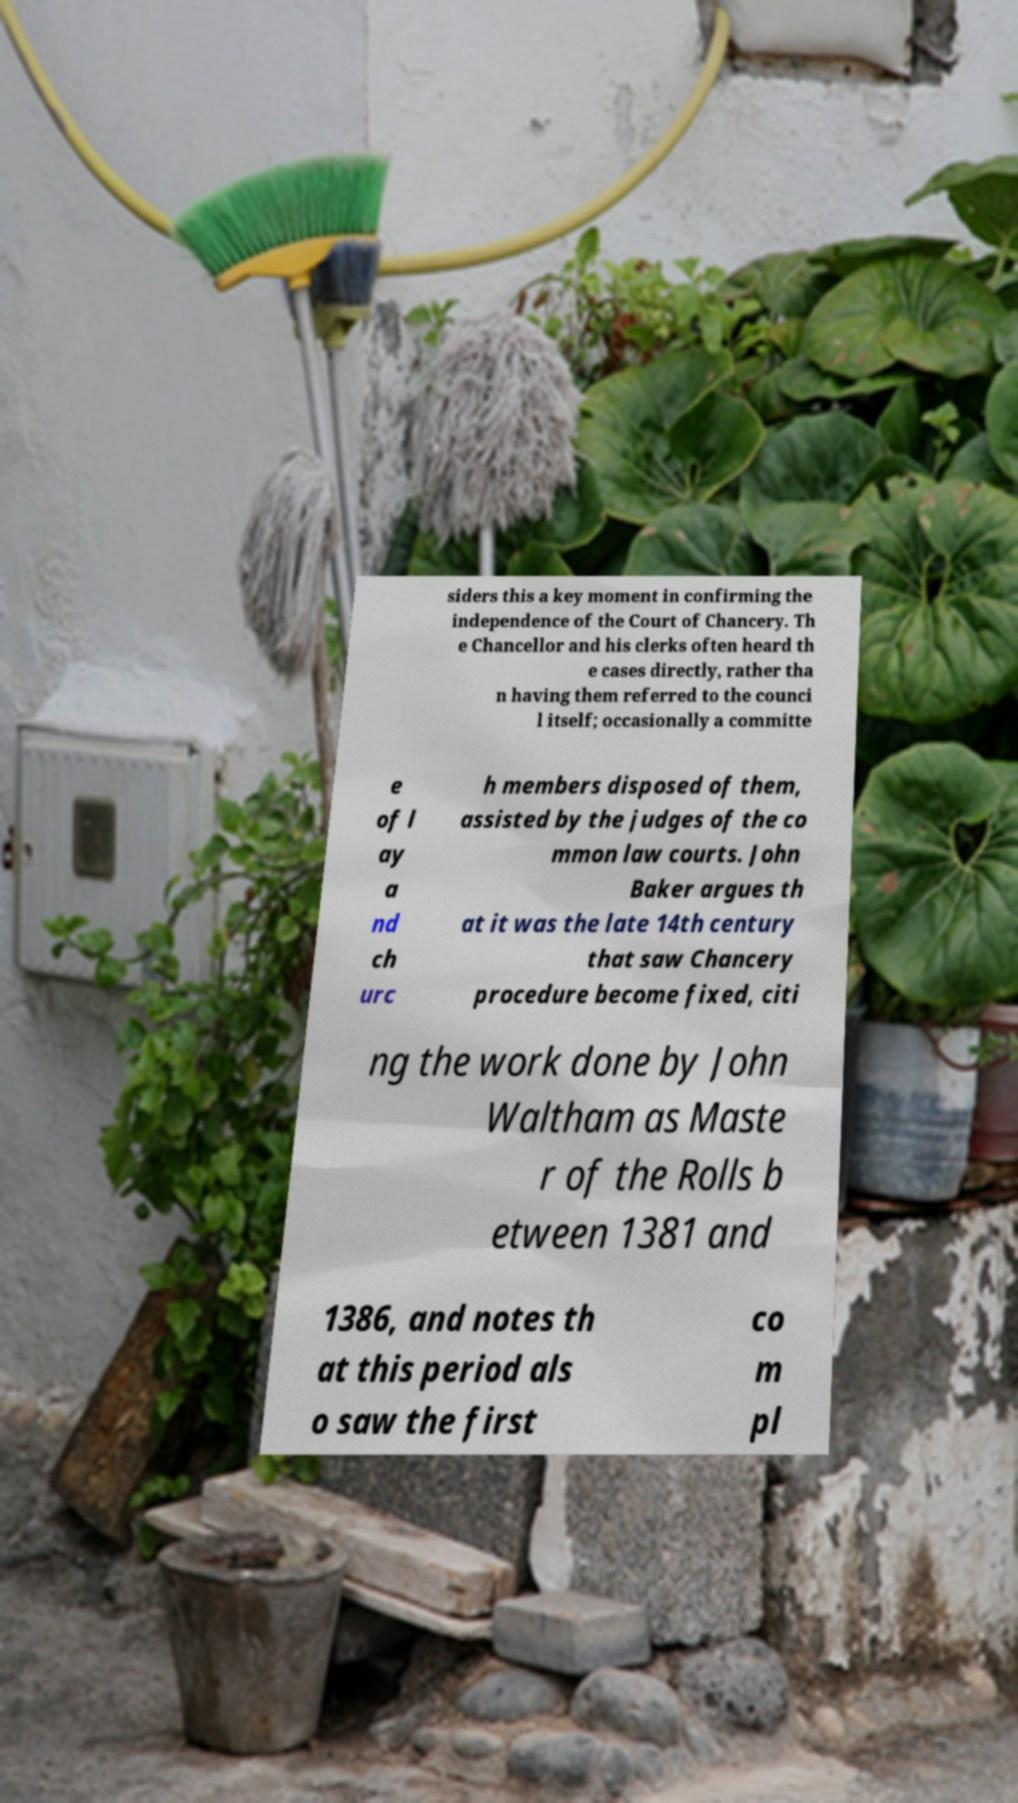Could you assist in decoding the text presented in this image and type it out clearly? siders this a key moment in confirming the independence of the Court of Chancery. Th e Chancellor and his clerks often heard th e cases directly, rather tha n having them referred to the counci l itself; occasionally a committe e of l ay a nd ch urc h members disposed of them, assisted by the judges of the co mmon law courts. John Baker argues th at it was the late 14th century that saw Chancery procedure become fixed, citi ng the work done by John Waltham as Maste r of the Rolls b etween 1381 and 1386, and notes th at this period als o saw the first co m pl 